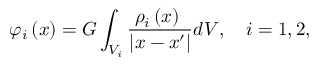Convert formula to latex. <formula><loc_0><loc_0><loc_500><loc_500>\varphi _ { i } \left ( x \right ) = G \int _ { V _ { i } } \frac { \rho _ { i } \left ( x \right ) \ } { | x - x ^ { \prime } | } d V , \quad i = 1 , 2 ,</formula> 